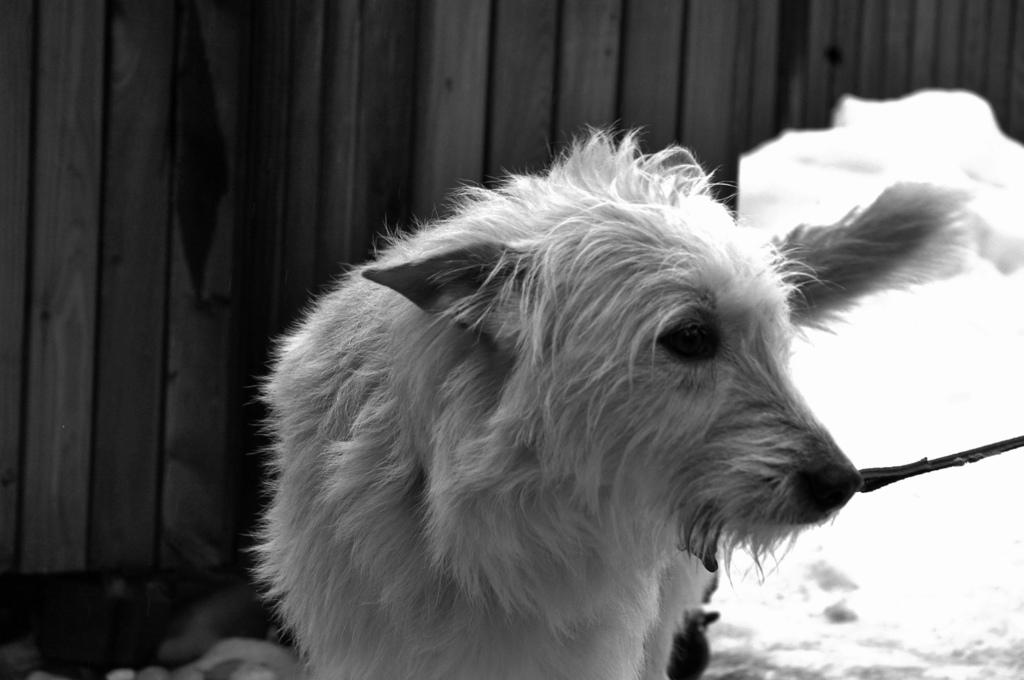What type of animal is in the image? There is a dog in the image. What can be seen in the background of the image? There is a wooden wall in the background of the image. What color scheme is used in the image? The image is black and white. What type of knot is the dog using to secure the attraction in the image? There is no knot or attraction present in the image; it features a dog and a wooden wall in a black and white setting. 